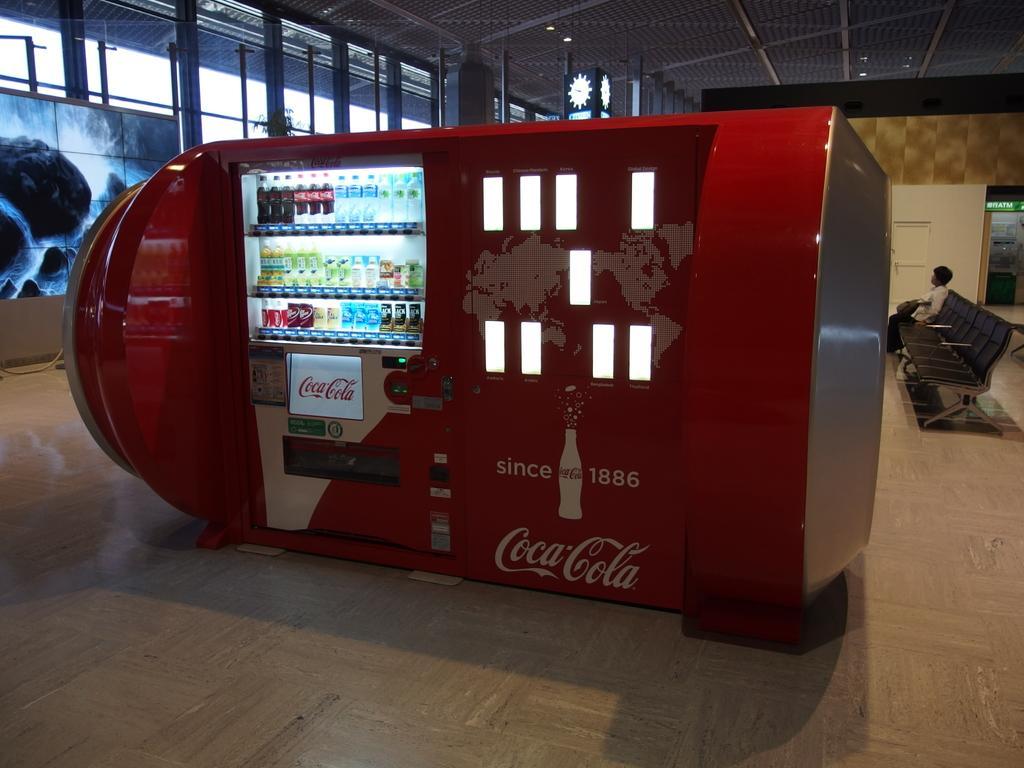Describe this image in one or two sentences. In this image we can see a coca cola machine, in the machine we can see some bottles, at the top we can see the roof, also we can see the chairs, poles, person, door and a screen. 